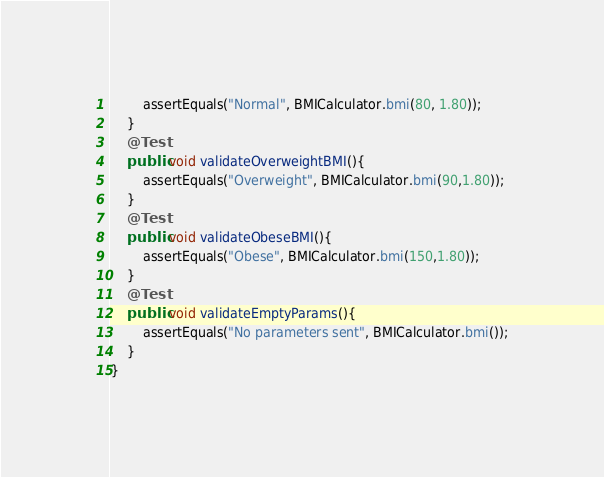Convert code to text. <code><loc_0><loc_0><loc_500><loc_500><_Java_>        assertEquals("Normal", BMICalculator.bmi(80, 1.80));
    }
    @Test
    public void validateOverweightBMI(){
        assertEquals("Overweight", BMICalculator.bmi(90,1.80));
    }
    @Test
    public void validateObeseBMI(){
        assertEquals("Obese", BMICalculator.bmi(150,1.80));
    }
    @Test
    public void validateEmptyParams(){
        assertEquals("No parameters sent", BMICalculator.bmi());
    }
}
</code> 